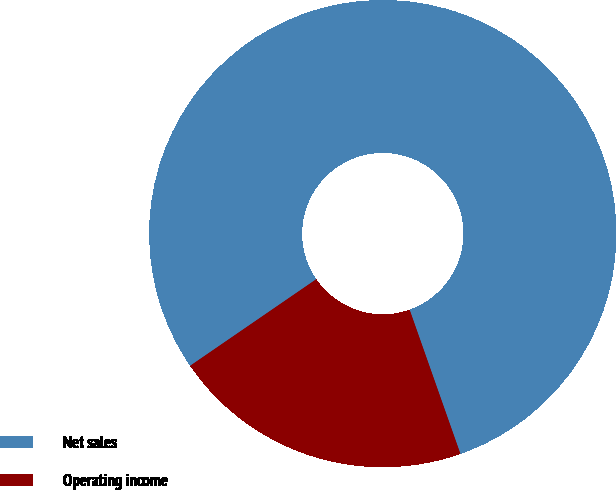Convert chart. <chart><loc_0><loc_0><loc_500><loc_500><pie_chart><fcel>Net sales<fcel>Operating income<nl><fcel>79.18%<fcel>20.82%<nl></chart> 